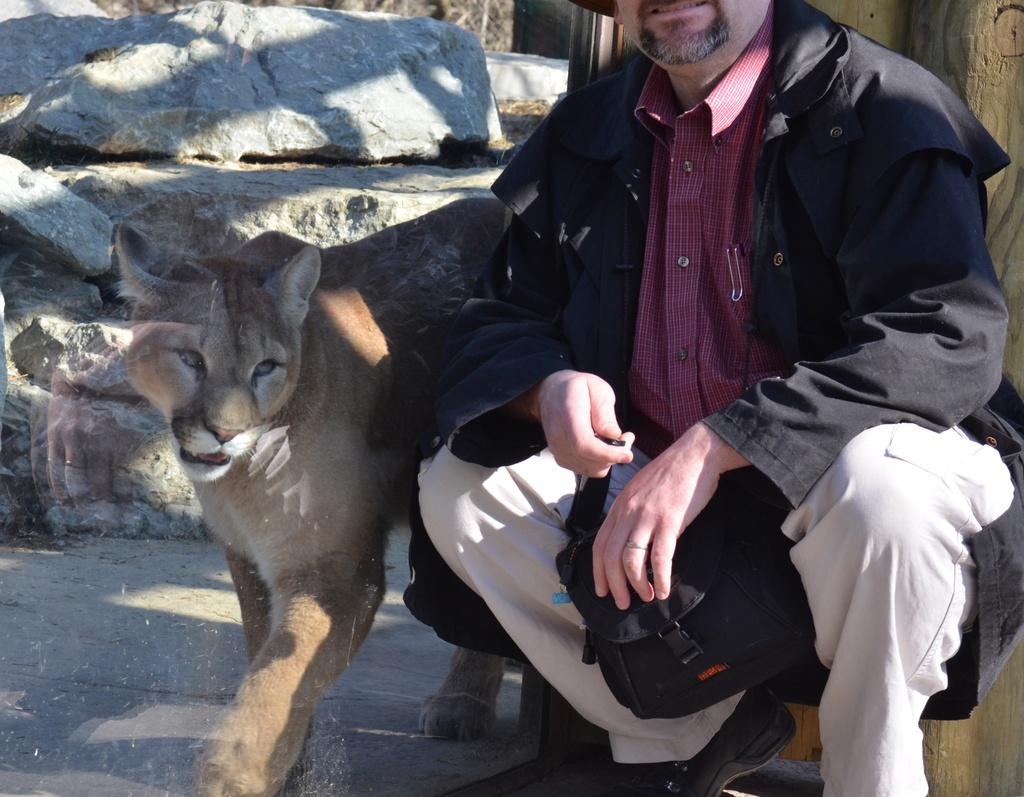Who or what is present in the image? There is a person in the image. What is the person doing in the image? The person is sitting beside a lioness. What is the person wearing in the image? The person is wearing a black jacket. How many cherries are on the person's head in the image? There are no cherries present on the person's head in the image. Can you compare the size of the lioness to the person in the image? The size of the lioness cannot be compared to the person in the image, as there is no reference point for scale provided. 